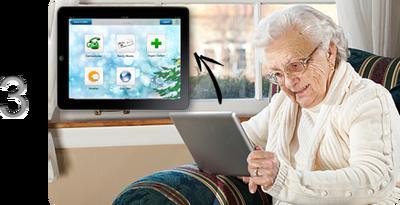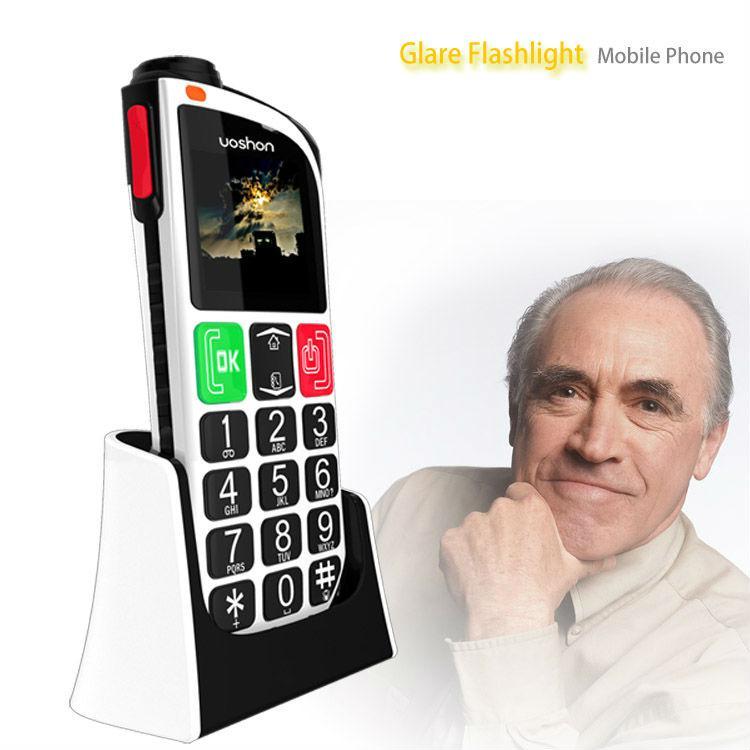The first image is the image on the left, the second image is the image on the right. Analyze the images presented: Is the assertion "In one image there is a red flip phone and in the other image there is a hand holding a grey and black phone." valid? Answer yes or no. No. The first image is the image on the left, the second image is the image on the right. For the images displayed, is the sentence "An image shows a gray-haired man with one hand on his chin and a phone on the left." factually correct? Answer yes or no. Yes. 